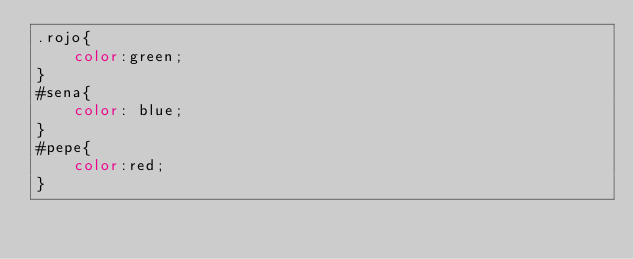Convert code to text. <code><loc_0><loc_0><loc_500><loc_500><_CSS_>.rojo{
	color:green;
}
#sena{
	color: blue;
}
#pepe{
	color:red;
}
</code> 